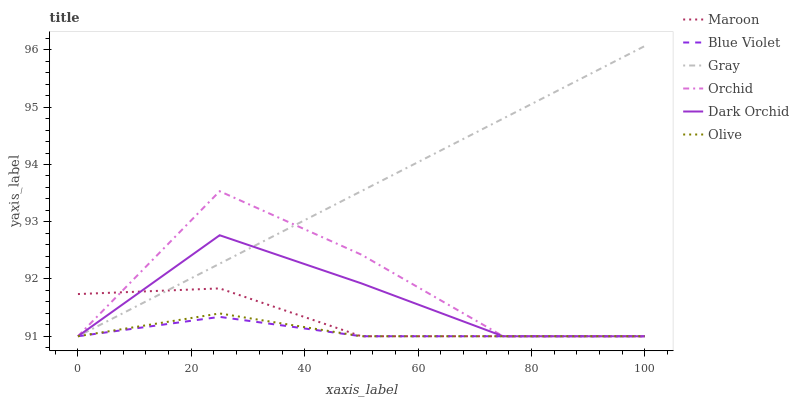Does Blue Violet have the minimum area under the curve?
Answer yes or no. Yes. Does Gray have the maximum area under the curve?
Answer yes or no. Yes. Does Dark Orchid have the minimum area under the curve?
Answer yes or no. No. Does Dark Orchid have the maximum area under the curve?
Answer yes or no. No. Is Gray the smoothest?
Answer yes or no. Yes. Is Orchid the roughest?
Answer yes or no. Yes. Is Dark Orchid the smoothest?
Answer yes or no. No. Is Dark Orchid the roughest?
Answer yes or no. No. Does Gray have the lowest value?
Answer yes or no. Yes. Does Gray have the highest value?
Answer yes or no. Yes. Does Dark Orchid have the highest value?
Answer yes or no. No. Does Olive intersect Gray?
Answer yes or no. Yes. Is Olive less than Gray?
Answer yes or no. No. Is Olive greater than Gray?
Answer yes or no. No. 